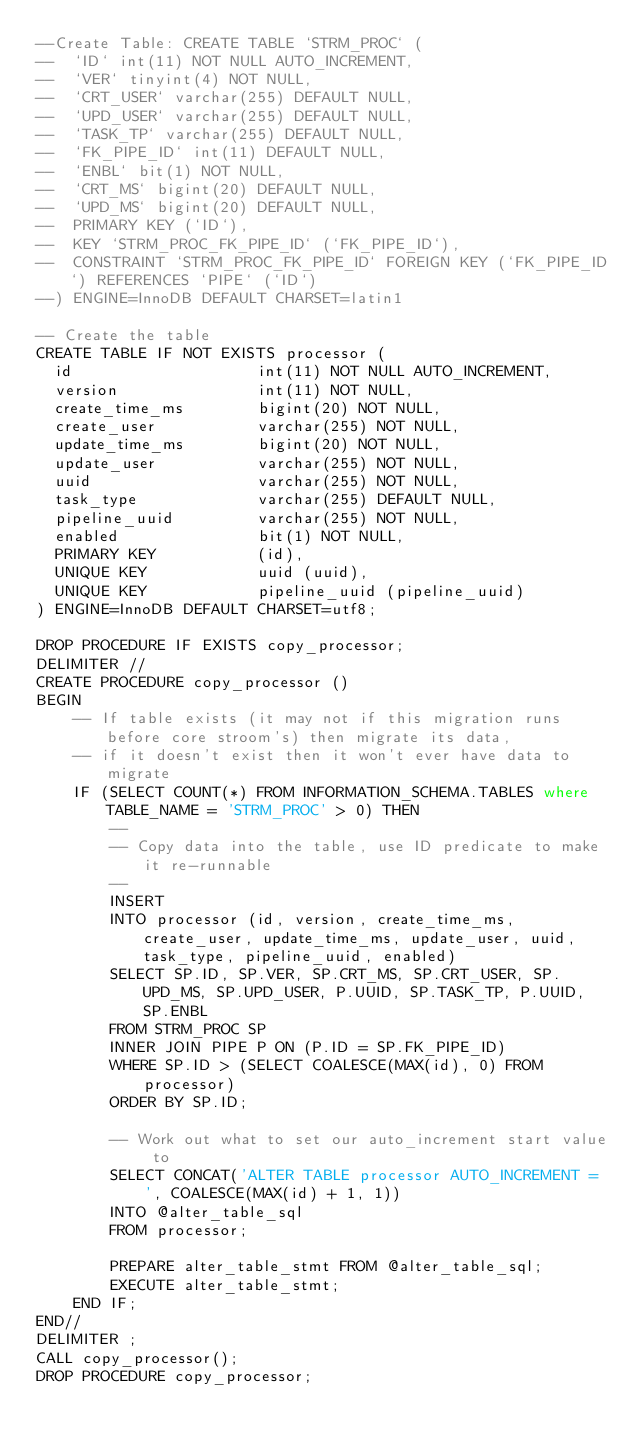<code> <loc_0><loc_0><loc_500><loc_500><_SQL_>--Create Table: CREATE TABLE `STRM_PROC` (
--  `ID` int(11) NOT NULL AUTO_INCREMENT,
--  `VER` tinyint(4) NOT NULL,
--  `CRT_USER` varchar(255) DEFAULT NULL,
--  `UPD_USER` varchar(255) DEFAULT NULL,
--  `TASK_TP` varchar(255) DEFAULT NULL,
--  `FK_PIPE_ID` int(11) DEFAULT NULL,
--  `ENBL` bit(1) NOT NULL,
--  `CRT_MS` bigint(20) DEFAULT NULL,
--  `UPD_MS` bigint(20) DEFAULT NULL,
--  PRIMARY KEY (`ID`),
--  KEY `STRM_PROC_FK_PIPE_ID` (`FK_PIPE_ID`),
--  CONSTRAINT `STRM_PROC_FK_PIPE_ID` FOREIGN KEY (`FK_PIPE_ID`) REFERENCES `PIPE` (`ID`)
--) ENGINE=InnoDB DEFAULT CHARSET=latin1

-- Create the table
CREATE TABLE IF NOT EXISTS processor (
  id                    int(11) NOT NULL AUTO_INCREMENT,
  version               int(11) NOT NULL,
  create_time_ms        bigint(20) NOT NULL,
  create_user           varchar(255) NOT NULL,
  update_time_ms        bigint(20) NOT NULL,
  update_user           varchar(255) NOT NULL,
  uuid          		varchar(255) NOT NULL,
  task_type             varchar(255) DEFAULT NULL,
  pipeline_uuid         varchar(255) NOT NULL,
  enabled               bit(1) NOT NULL,
  PRIMARY KEY           (id),
  UNIQUE KEY            uuid (uuid),
  UNIQUE KEY		    pipeline_uuid (pipeline_uuid)
) ENGINE=InnoDB DEFAULT CHARSET=utf8;

DROP PROCEDURE IF EXISTS copy_processor;
DELIMITER //
CREATE PROCEDURE copy_processor ()
BEGIN
    -- If table exists (it may not if this migration runs before core stroom's) then migrate its data,
    -- if it doesn't exist then it won't ever have data to migrate
    IF (SELECT COUNT(*) FROM INFORMATION_SCHEMA.TABLES where TABLE_NAME = 'STRM_PROC' > 0) THEN
        --
        -- Copy data into the table, use ID predicate to make it re-runnable
        --
        INSERT
        INTO processor (id, version, create_time_ms, create_user, update_time_ms, update_user, uuid, task_type, pipeline_uuid, enabled)
        SELECT SP.ID, SP.VER, SP.CRT_MS, SP.CRT_USER, SP.UPD_MS, SP.UPD_USER, P.UUID, SP.TASK_TP, P.UUID, SP.ENBL
        FROM STRM_PROC SP
        INNER JOIN PIPE P ON (P.ID = SP.FK_PIPE_ID)
        WHERE SP.ID > (SELECT COALESCE(MAX(id), 0) FROM processor)
        ORDER BY SP.ID;

        -- Work out what to set our auto_increment start value to
        SELECT CONCAT('ALTER TABLE processor AUTO_INCREMENT = ', COALESCE(MAX(id) + 1, 1))
        INTO @alter_table_sql
        FROM processor;

        PREPARE alter_table_stmt FROM @alter_table_sql;
        EXECUTE alter_table_stmt;
    END IF;
END//
DELIMITER ;
CALL copy_processor();
DROP PROCEDURE copy_processor;

</code> 